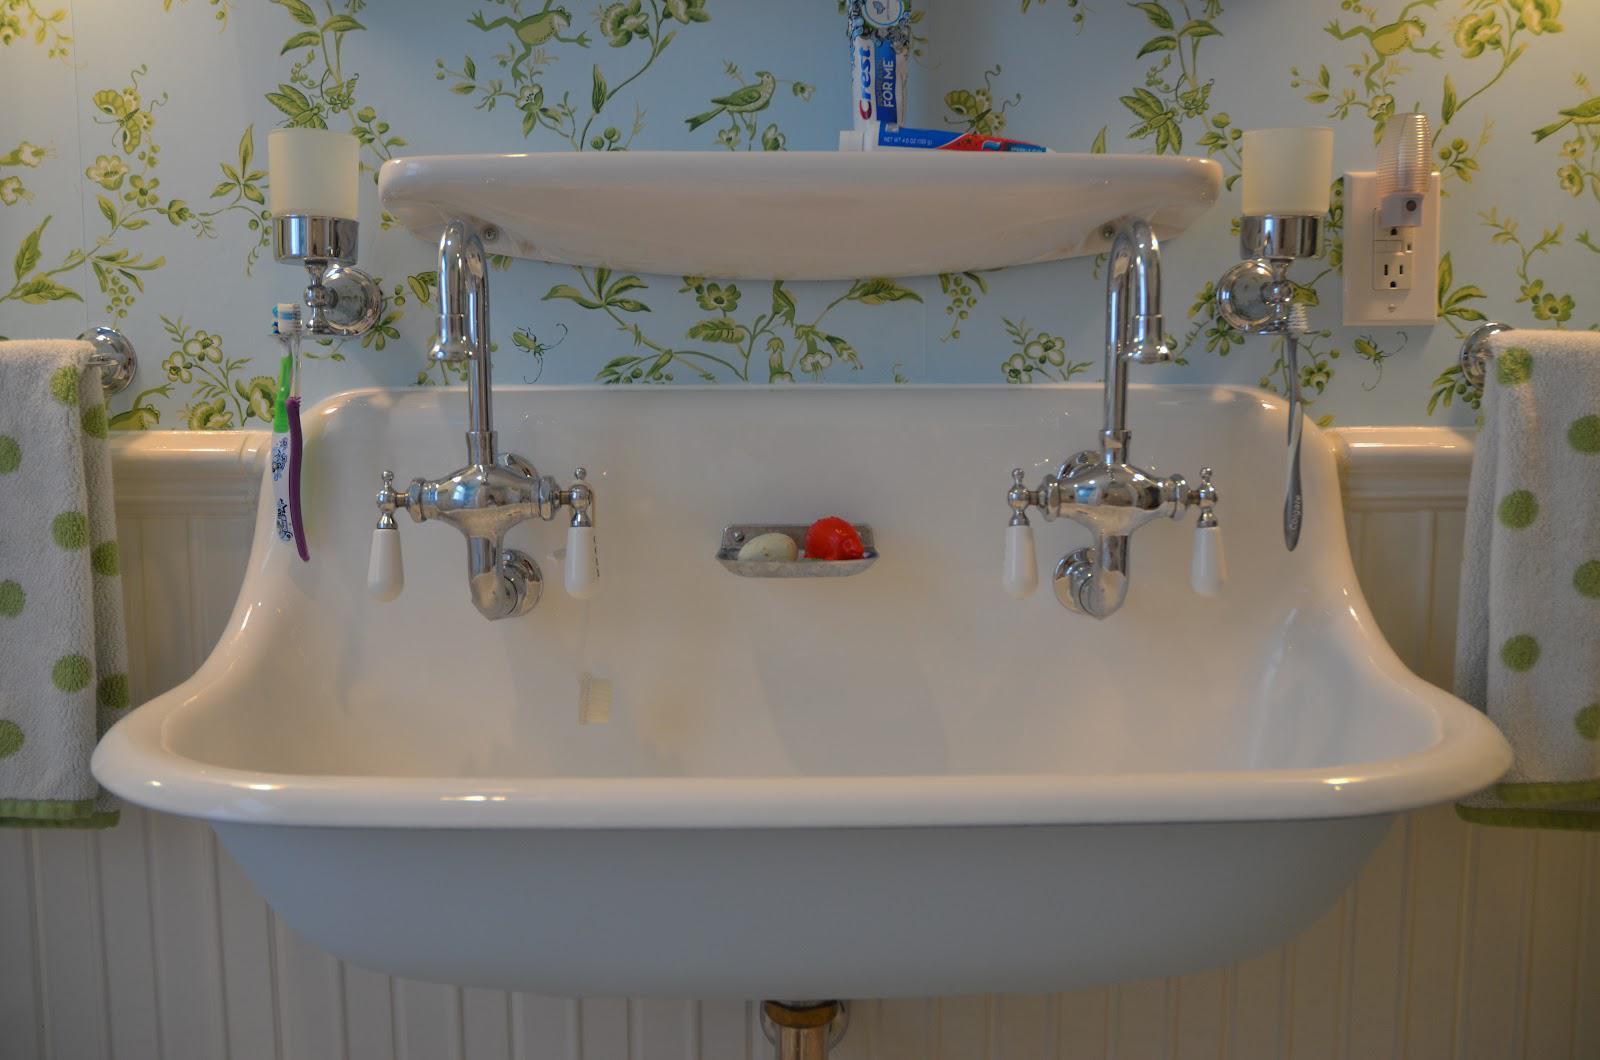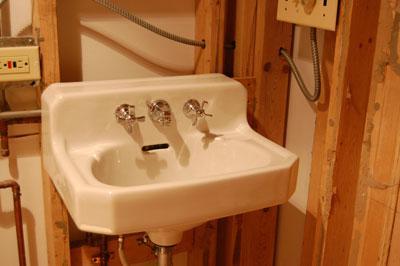The first image is the image on the left, the second image is the image on the right. For the images displayed, is the sentence "A mirror sits above the sink in the image on the left." factually correct? Answer yes or no. No. The first image is the image on the left, the second image is the image on the right. For the images shown, is this caption "A white sink on a wooden vanity angles up at the back to form its own backsplash and has chrome faucets with bell-shaped ends." true? Answer yes or no. No. 